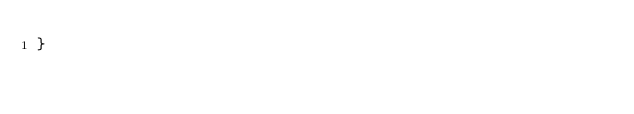Convert code to text. <code><loc_0><loc_0><loc_500><loc_500><_C_>}

</code> 